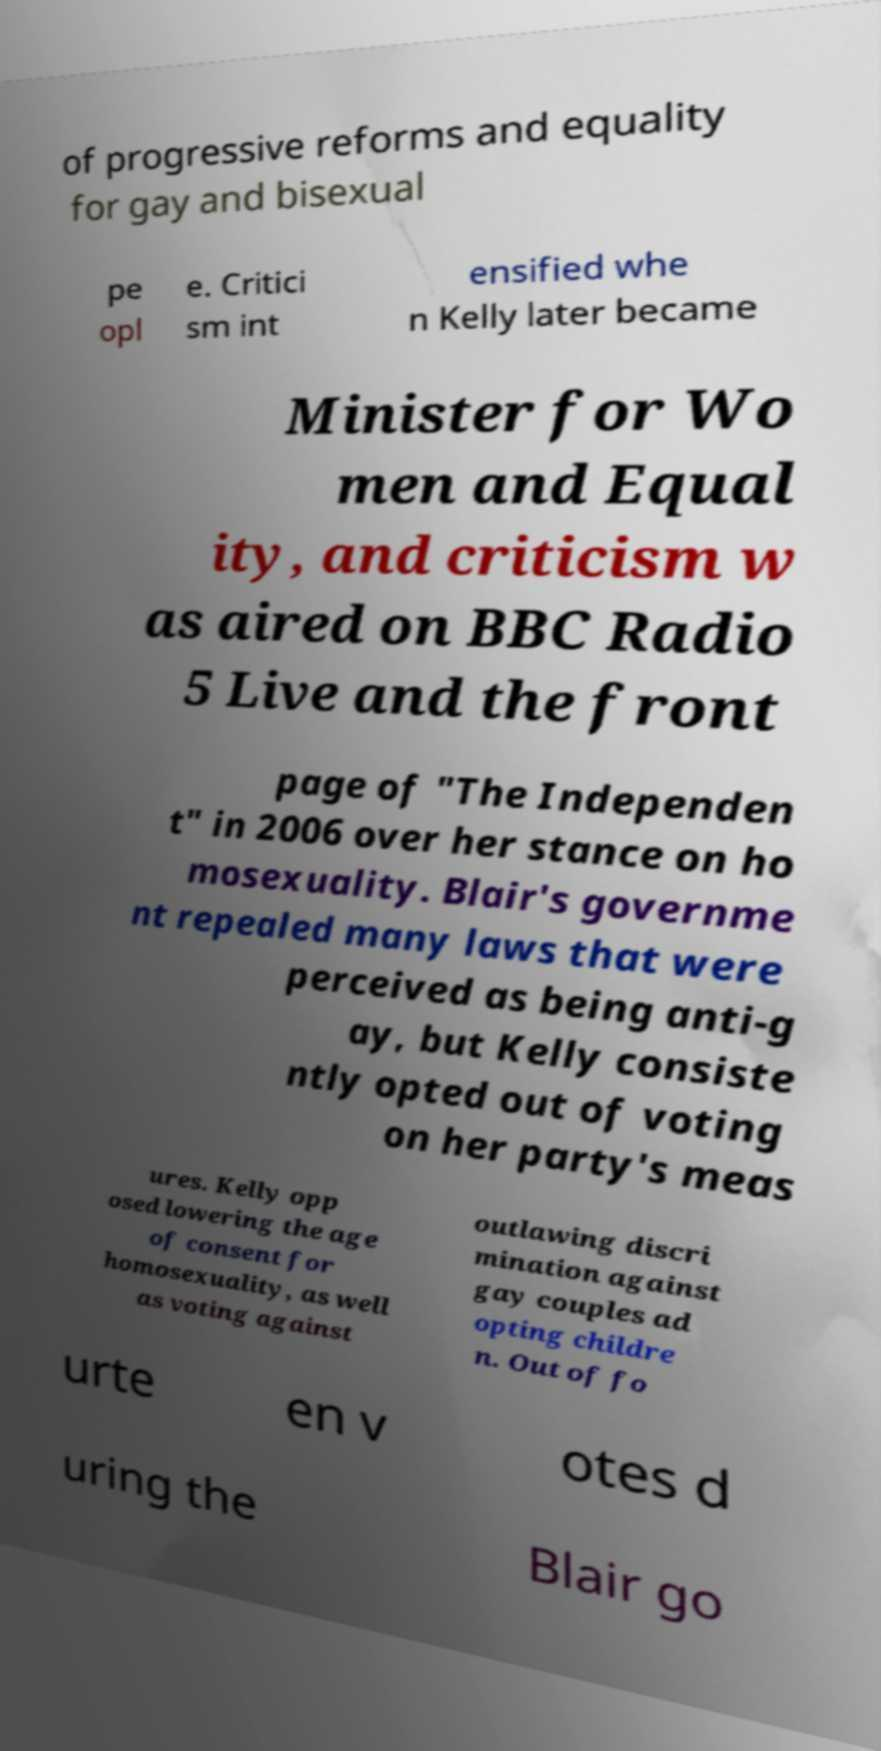Could you extract and type out the text from this image? of progressive reforms and equality for gay and bisexual pe opl e. Critici sm int ensified whe n Kelly later became Minister for Wo men and Equal ity, and criticism w as aired on BBC Radio 5 Live and the front page of "The Independen t" in 2006 over her stance on ho mosexuality. Blair's governme nt repealed many laws that were perceived as being anti-g ay, but Kelly consiste ntly opted out of voting on her party's meas ures. Kelly opp osed lowering the age of consent for homosexuality, as well as voting against outlawing discri mination against gay couples ad opting childre n. Out of fo urte en v otes d uring the Blair go 